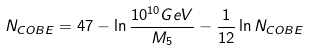Convert formula to latex. <formula><loc_0><loc_0><loc_500><loc_500>N _ { C O B E } = 4 7 - \ln \frac { 1 0 ^ { 1 0 } G e V } { M _ { 5 } } - \frac { 1 } { 1 2 } \ln N _ { C O B E }</formula> 